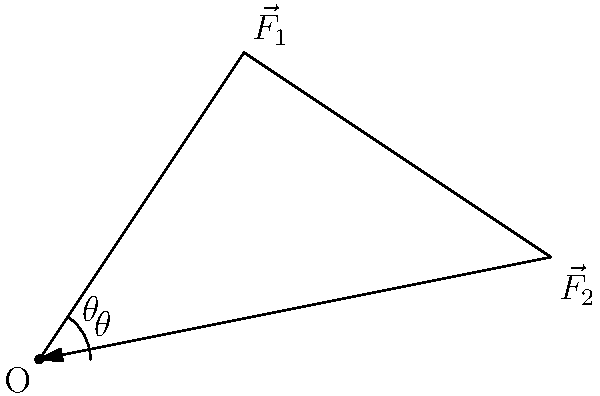During a Vikings game, a linebacker tackles a running back. The linebacker applies two forces: $\vec{F}_1$ of magnitude 800 N at an angle of 30° above the horizontal, and $\vec{F}_2$ of magnitude 600 N at an angle of 15° below the horizontal. What is the magnitude of the resultant force on the running back? To solve this problem, we'll use vector addition and the law of cosines. Here's a step-by-step approach:

1) First, let's identify the components of each force:

   $\vec{F}_1$: 800 N at 30° above horizontal
   $\vec{F}_2$: 600 N at 15° below horizontal

2) The angle between these vectors is:
   $\theta = 30° + 15° = 45°$

3) We can use the law of cosines to find the magnitude of the resultant force:

   $F_R^2 = F_1^2 + F_2^2 - 2F_1F_2\cos\theta$

4) Substituting the values:

   $F_R^2 = 800^2 + 600^2 - 2(800)(600)\cos(45°)$

5) Simplify:
   $F_R^2 = 640,000 + 360,000 - 960,000\cos(45°)$
   $F_R^2 = 1,000,000 - 960,000 \cdot 0.7071$
   $F_R^2 = 1,000,000 - 678,816$
   $F_R^2 = 321,184$

6) Take the square root of both sides:
   $F_R = \sqrt{321,184} \approx 566.73$ N

Therefore, the magnitude of the resultant force is approximately 567 N.
Answer: 567 N 